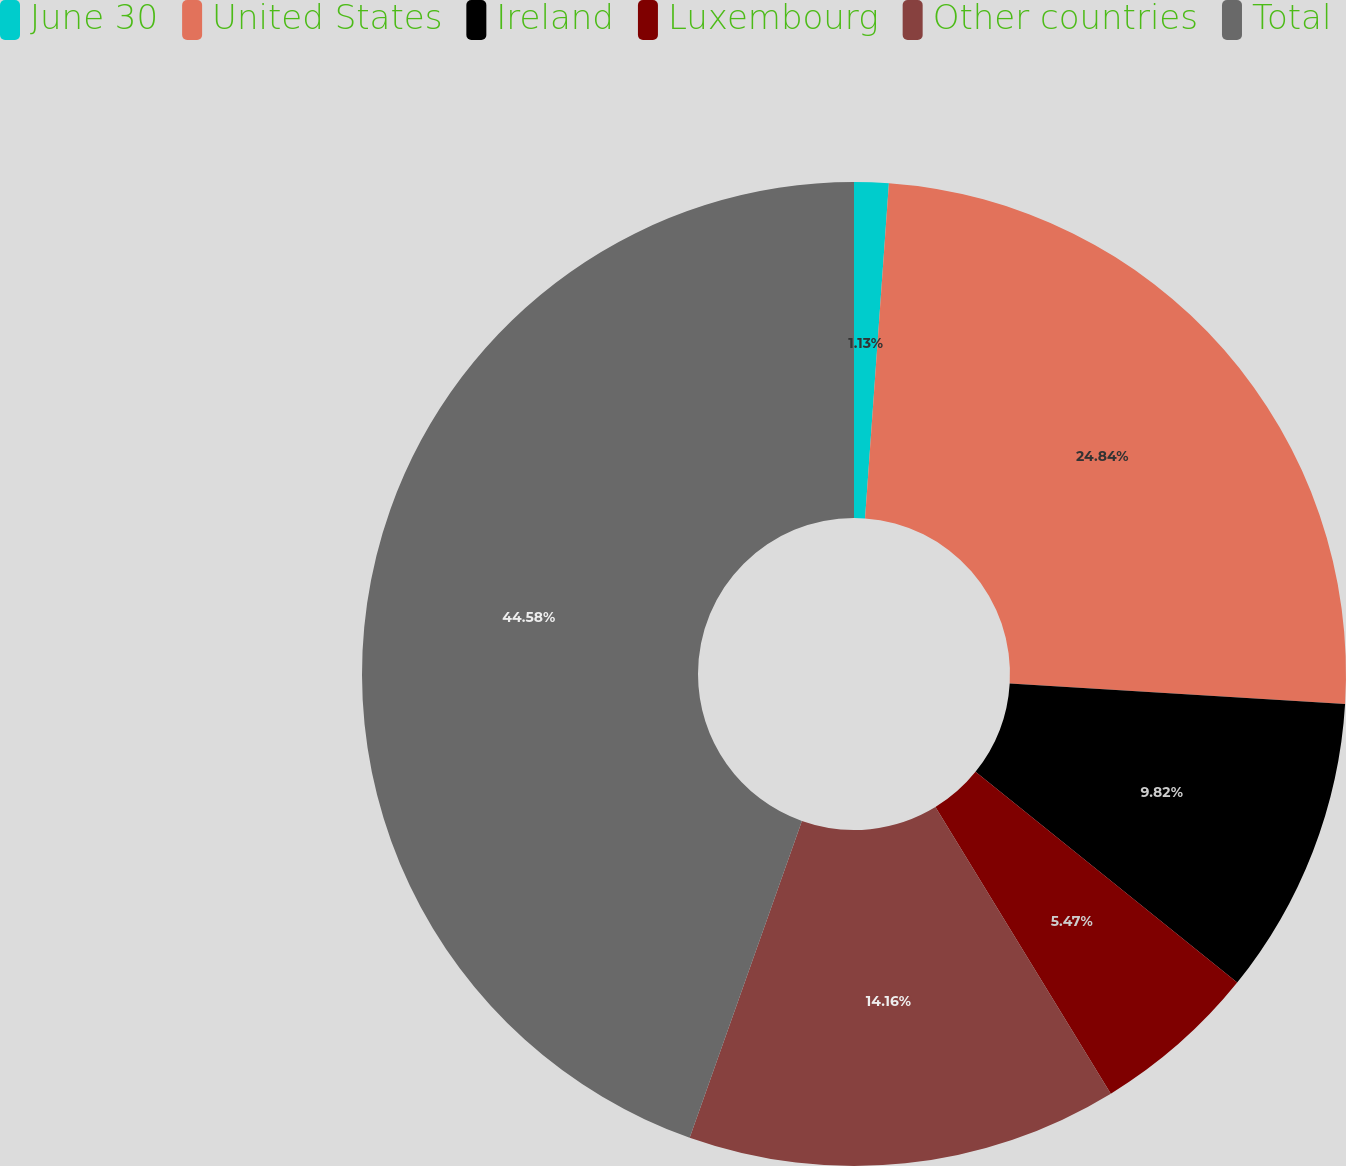Convert chart to OTSL. <chart><loc_0><loc_0><loc_500><loc_500><pie_chart><fcel>June 30<fcel>United States<fcel>Ireland<fcel>Luxembourg<fcel>Other countries<fcel>Total<nl><fcel>1.13%<fcel>24.84%<fcel>9.82%<fcel>5.47%<fcel>14.16%<fcel>44.58%<nl></chart> 